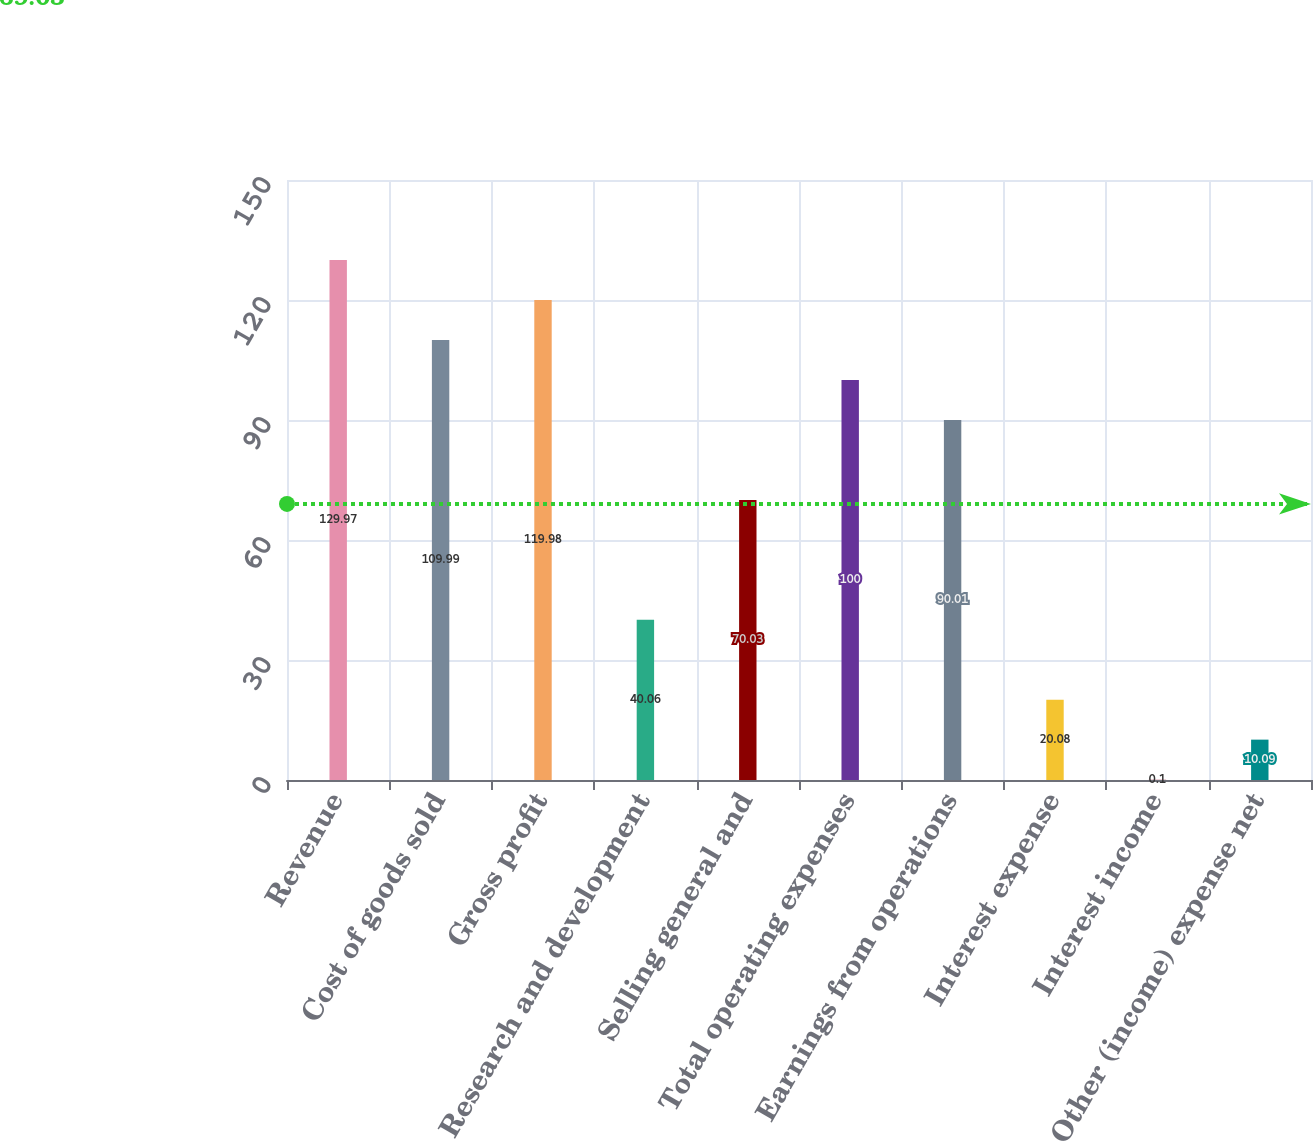<chart> <loc_0><loc_0><loc_500><loc_500><bar_chart><fcel>Revenue<fcel>Cost of goods sold<fcel>Gross profit<fcel>Research and development<fcel>Selling general and<fcel>Total operating expenses<fcel>Earnings from operations<fcel>Interest expense<fcel>Interest income<fcel>Other (income) expense net<nl><fcel>129.97<fcel>109.99<fcel>119.98<fcel>40.06<fcel>70.03<fcel>100<fcel>90.01<fcel>20.08<fcel>0.1<fcel>10.09<nl></chart> 